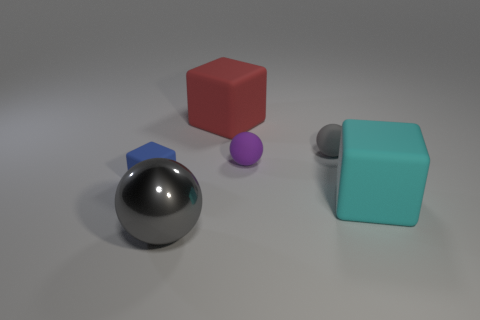Subtract all large spheres. How many spheres are left? 2 Subtract all blue blocks. How many gray balls are left? 2 Add 1 cyan things. How many objects exist? 7 Subtract 3 cubes. How many cubes are left? 0 Subtract all purple balls. How many balls are left? 2 Subtract all yellow cubes. Subtract all gray cylinders. How many cubes are left? 3 Subtract all big rubber balls. Subtract all large matte things. How many objects are left? 4 Add 2 metal spheres. How many metal spheres are left? 3 Add 4 large blue cubes. How many large blue cubes exist? 4 Subtract 1 purple balls. How many objects are left? 5 